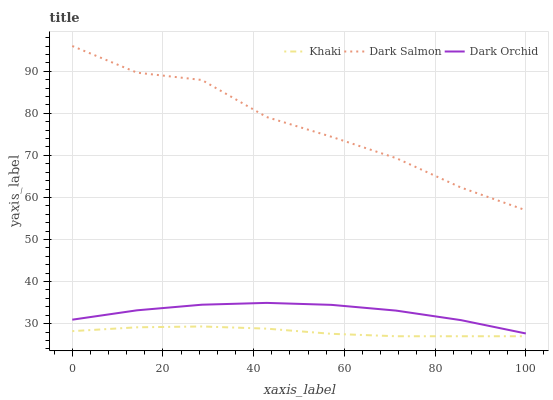Does Khaki have the minimum area under the curve?
Answer yes or no. Yes. Does Dark Salmon have the maximum area under the curve?
Answer yes or no. Yes. Does Dark Orchid have the minimum area under the curve?
Answer yes or no. No. Does Dark Orchid have the maximum area under the curve?
Answer yes or no. No. Is Khaki the smoothest?
Answer yes or no. Yes. Is Dark Salmon the roughest?
Answer yes or no. Yes. Is Dark Orchid the smoothest?
Answer yes or no. No. Is Dark Orchid the roughest?
Answer yes or no. No. Does Khaki have the lowest value?
Answer yes or no. Yes. Does Dark Orchid have the lowest value?
Answer yes or no. No. Does Dark Salmon have the highest value?
Answer yes or no. Yes. Does Dark Orchid have the highest value?
Answer yes or no. No. Is Khaki less than Dark Salmon?
Answer yes or no. Yes. Is Dark Orchid greater than Khaki?
Answer yes or no. Yes. Does Khaki intersect Dark Salmon?
Answer yes or no. No. 